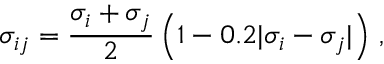Convert formula to latex. <formula><loc_0><loc_0><loc_500><loc_500>\sigma _ { i j } = \frac { \sigma _ { i } + \sigma _ { j } } { 2 } \left ( 1 - 0 . 2 | \sigma _ { i } - \sigma _ { j } | \right ) \, ,</formula> 